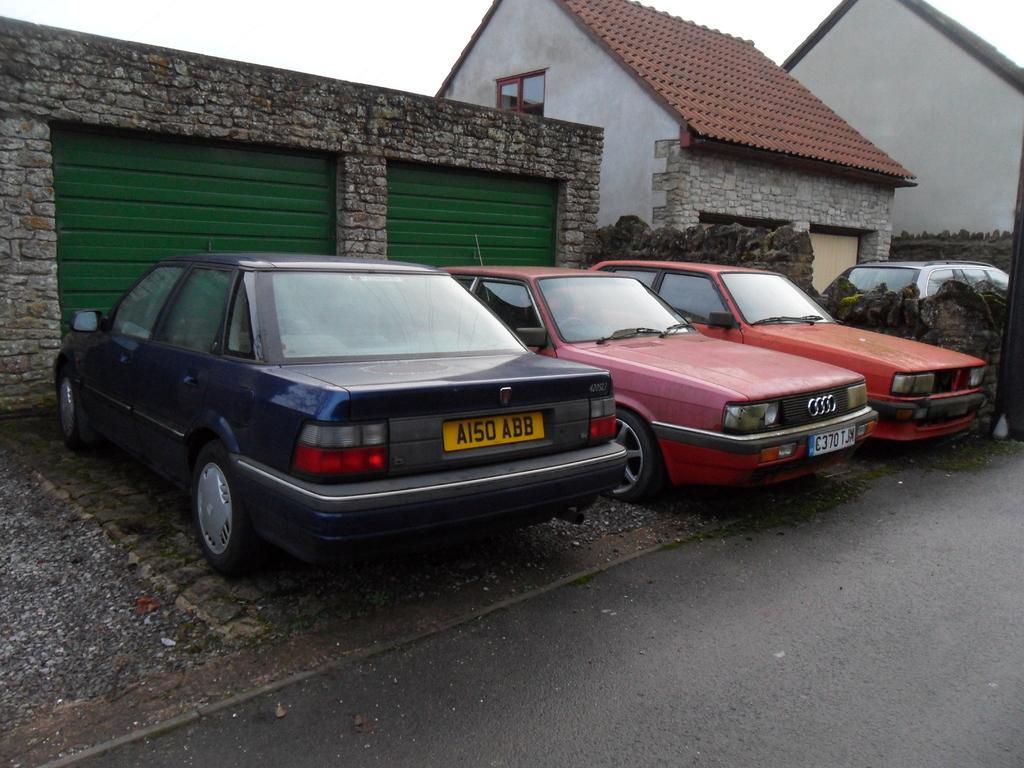Can you describe this image briefly? In this image, there are a few vehicles and houses. We can see the wall with some objects. We can see the ground and the sky. 